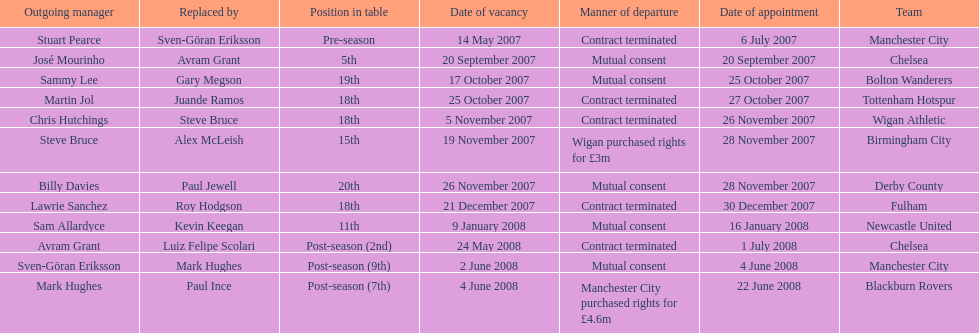How many teams had a manner of departure due to there contract being terminated? 5. 